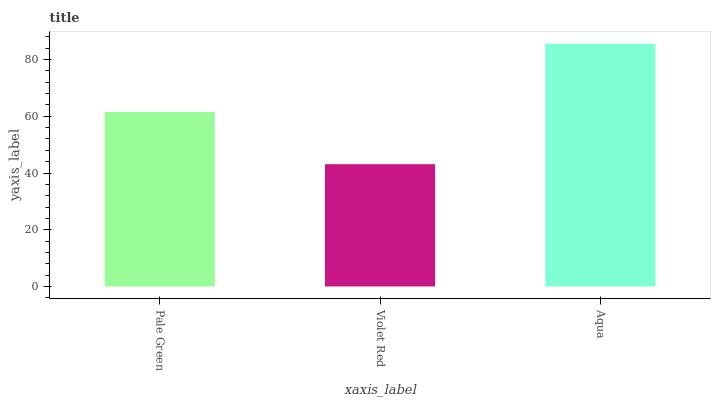Is Aqua the minimum?
Answer yes or no. No. Is Violet Red the maximum?
Answer yes or no. No. Is Aqua greater than Violet Red?
Answer yes or no. Yes. Is Violet Red less than Aqua?
Answer yes or no. Yes. Is Violet Red greater than Aqua?
Answer yes or no. No. Is Aqua less than Violet Red?
Answer yes or no. No. Is Pale Green the high median?
Answer yes or no. Yes. Is Pale Green the low median?
Answer yes or no. Yes. Is Violet Red the high median?
Answer yes or no. No. Is Aqua the low median?
Answer yes or no. No. 